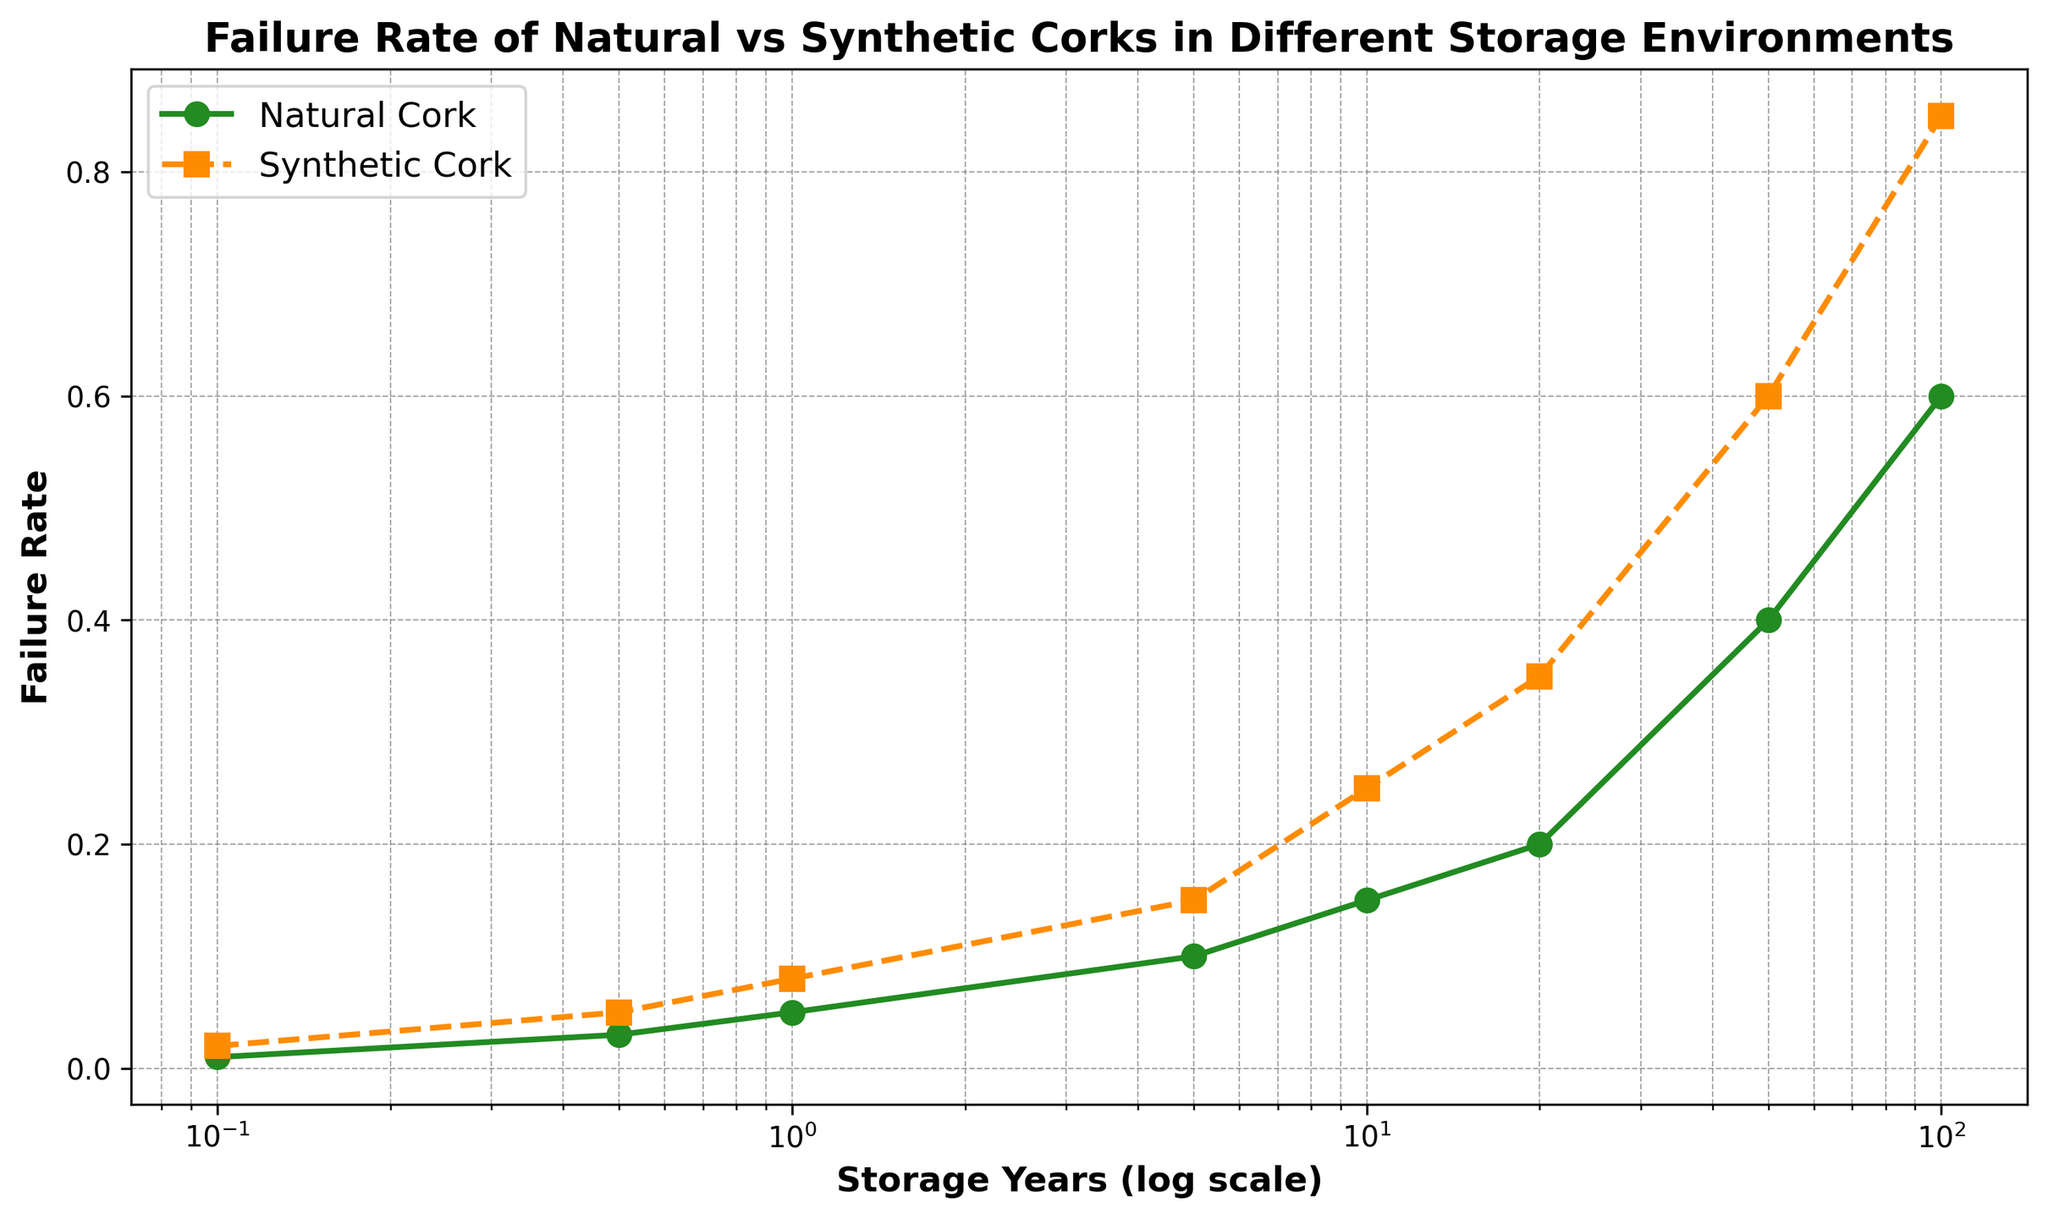What is the failure rate for natural corks after 10 years compared to synthetic corks? By looking at the figure, find the data points for both natural and synthetic corks at the 10-year mark. The failure rate for natural corks is where the line with round green markers intersects the 10-year point. Similarly, the failure rate for synthetic corks is where the line with square orange markers intersects the 10-year point.
Answer: 0.15 for natural, 0.25 for synthetic What is the trend in failure rates for both types of corks as storage years increase? Observe the overall slope and direction of the lines representing natural and synthetic corks. Both lines show an upward trend, indicating that failure rates increase as storage years increase. However, the failure rate for synthetic corks increases more steeply compared to natural corks.
Answer: Increasing trend for both, steeper for synthetic At the 50-year mark, which type of cork has a higher failure rate, and by how much? Find the data points for 50 years on the x-axis. Observe the corresponding failure rates for both natural and synthetic corks. The synthetic cork's failure rate is 0.6, and the natural cork's failure rate is 0.4. Subtract the failure rate of natural cork from that of synthetic cork.
Answer: Synthetic by 0.2 What is the difference in failure rates between natural and synthetic corks after 100 years? Find the data points for 100 years on the x-axis. Observe the failure rates for both natural (0.6) and synthetic corks (0.85). Subtract the failure rate of natural cork from that of synthetic cork.
Answer: 0.25 How does the failure rate of synthetic corks change from 1 year to 20 years? Locate the points for synthetic corks at 1 year (0.08) and 20 years (0.35). Subtract the former from the latter to find the change in failure rate.
Answer: Increases by 0.27 What can be inferred about the reliability of natural corks for short-term storage (0.1 years) compared to long-term storage (100 years)? Compare the failure rates at 0.1 years (0.01) and 100 years (0.6) for natural corks. The failure rate increases significantly, indicating that natural corks are more reliable for short-term storage compared to long-term storage.
Answer: More reliable for short-term For which type of cork does the failure rate exceed 0.5 first, and after how many years? Locate the points where the failure rates cross the 0.5 mark on the y-axis for both cork types. The synthetic cork reaches 0.5 at around 50 years, while the natural cork does not reach 0.5 until approximately 100 years.
Answer: Synthetic after 50 years What is the relative difference in failure rates between natural and synthetic corks after 5 years? Find the failure rates for both natural (0.1) and synthetic corks (0.15) at 5 years. Calculate the relative difference using the formula: (rate_synthetic - rate_natural) / rate_natural.
Answer: 50% How does the failure rate for natural corks compare between the first and last data points in the figure? Observe the failure rates for natural corks at the initial point (0.1 years, 0.01) and the final point (100 years, 0.6). Subtract the initial failure rate from the final failure rate.
Answer: Increases by 0.59 If a winemaker wants to store wine for 20 years, which type of cork should they prefer based on failure rates? Compare the failure rates of both natural (0.2) and synthetic corks (0.35) at the 20-year mark. Since the failure rate for natural corks is lower, it is the preferred choice for long-term storage.
Answer: Natural cork 